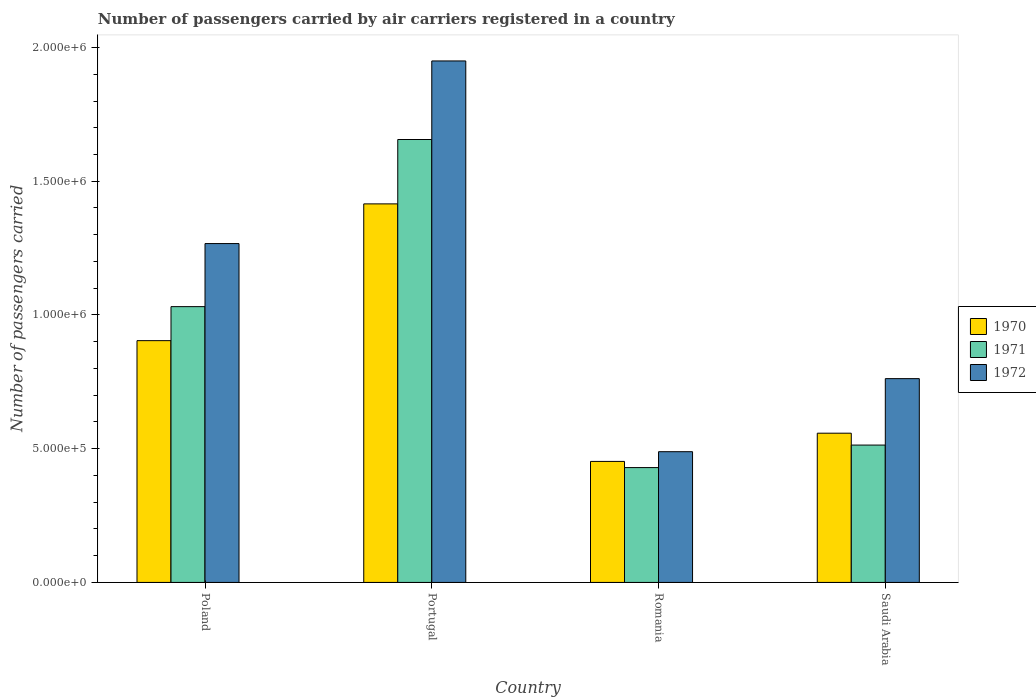How many different coloured bars are there?
Provide a succinct answer. 3. How many groups of bars are there?
Give a very brief answer. 4. Are the number of bars per tick equal to the number of legend labels?
Keep it short and to the point. Yes. How many bars are there on the 1st tick from the left?
Keep it short and to the point. 3. What is the number of passengers carried by air carriers in 1970 in Poland?
Ensure brevity in your answer.  9.04e+05. Across all countries, what is the maximum number of passengers carried by air carriers in 1972?
Provide a short and direct response. 1.95e+06. Across all countries, what is the minimum number of passengers carried by air carriers in 1972?
Offer a terse response. 4.89e+05. In which country was the number of passengers carried by air carriers in 1971 minimum?
Make the answer very short. Romania. What is the total number of passengers carried by air carriers in 1971 in the graph?
Offer a very short reply. 3.63e+06. What is the difference between the number of passengers carried by air carriers in 1970 in Poland and that in Romania?
Provide a short and direct response. 4.52e+05. What is the difference between the number of passengers carried by air carriers in 1971 in Poland and the number of passengers carried by air carriers in 1970 in Saudi Arabia?
Ensure brevity in your answer.  4.73e+05. What is the average number of passengers carried by air carriers in 1970 per country?
Provide a short and direct response. 8.32e+05. What is the difference between the number of passengers carried by air carriers of/in 1971 and number of passengers carried by air carriers of/in 1970 in Romania?
Provide a succinct answer. -2.31e+04. In how many countries, is the number of passengers carried by air carriers in 1971 greater than 1000000?
Offer a terse response. 2. What is the ratio of the number of passengers carried by air carriers in 1971 in Poland to that in Saudi Arabia?
Provide a short and direct response. 2.01. What is the difference between the highest and the second highest number of passengers carried by air carriers in 1970?
Your response must be concise. 5.11e+05. What is the difference between the highest and the lowest number of passengers carried by air carriers in 1971?
Your answer should be very brief. 1.23e+06. Is the sum of the number of passengers carried by air carriers in 1970 in Poland and Portugal greater than the maximum number of passengers carried by air carriers in 1971 across all countries?
Make the answer very short. Yes. What does the 2nd bar from the left in Poland represents?
Ensure brevity in your answer.  1971. How many bars are there?
Your answer should be compact. 12. How many countries are there in the graph?
Give a very brief answer. 4. Where does the legend appear in the graph?
Your answer should be very brief. Center right. What is the title of the graph?
Ensure brevity in your answer.  Number of passengers carried by air carriers registered in a country. What is the label or title of the X-axis?
Offer a terse response. Country. What is the label or title of the Y-axis?
Give a very brief answer. Number of passengers carried. What is the Number of passengers carried in 1970 in Poland?
Give a very brief answer. 9.04e+05. What is the Number of passengers carried in 1971 in Poland?
Offer a very short reply. 1.03e+06. What is the Number of passengers carried of 1972 in Poland?
Make the answer very short. 1.27e+06. What is the Number of passengers carried in 1970 in Portugal?
Your response must be concise. 1.42e+06. What is the Number of passengers carried in 1971 in Portugal?
Give a very brief answer. 1.66e+06. What is the Number of passengers carried of 1972 in Portugal?
Offer a terse response. 1.95e+06. What is the Number of passengers carried in 1970 in Romania?
Your answer should be very brief. 4.52e+05. What is the Number of passengers carried of 1971 in Romania?
Keep it short and to the point. 4.29e+05. What is the Number of passengers carried of 1972 in Romania?
Offer a terse response. 4.89e+05. What is the Number of passengers carried of 1970 in Saudi Arabia?
Give a very brief answer. 5.58e+05. What is the Number of passengers carried in 1971 in Saudi Arabia?
Offer a very short reply. 5.14e+05. What is the Number of passengers carried of 1972 in Saudi Arabia?
Provide a succinct answer. 7.62e+05. Across all countries, what is the maximum Number of passengers carried in 1970?
Give a very brief answer. 1.42e+06. Across all countries, what is the maximum Number of passengers carried of 1971?
Your answer should be compact. 1.66e+06. Across all countries, what is the maximum Number of passengers carried of 1972?
Ensure brevity in your answer.  1.95e+06. Across all countries, what is the minimum Number of passengers carried in 1970?
Offer a terse response. 4.52e+05. Across all countries, what is the minimum Number of passengers carried of 1971?
Make the answer very short. 4.29e+05. Across all countries, what is the minimum Number of passengers carried of 1972?
Provide a succinct answer. 4.89e+05. What is the total Number of passengers carried of 1970 in the graph?
Your response must be concise. 3.33e+06. What is the total Number of passengers carried of 1971 in the graph?
Your answer should be compact. 3.63e+06. What is the total Number of passengers carried of 1972 in the graph?
Ensure brevity in your answer.  4.47e+06. What is the difference between the Number of passengers carried in 1970 in Poland and that in Portugal?
Provide a short and direct response. -5.11e+05. What is the difference between the Number of passengers carried in 1971 in Poland and that in Portugal?
Your answer should be compact. -6.25e+05. What is the difference between the Number of passengers carried of 1972 in Poland and that in Portugal?
Your answer should be very brief. -6.83e+05. What is the difference between the Number of passengers carried of 1970 in Poland and that in Romania?
Give a very brief answer. 4.52e+05. What is the difference between the Number of passengers carried of 1971 in Poland and that in Romania?
Give a very brief answer. 6.02e+05. What is the difference between the Number of passengers carried of 1972 in Poland and that in Romania?
Provide a succinct answer. 7.78e+05. What is the difference between the Number of passengers carried in 1970 in Poland and that in Saudi Arabia?
Your response must be concise. 3.46e+05. What is the difference between the Number of passengers carried of 1971 in Poland and that in Saudi Arabia?
Your answer should be very brief. 5.18e+05. What is the difference between the Number of passengers carried of 1972 in Poland and that in Saudi Arabia?
Offer a terse response. 5.05e+05. What is the difference between the Number of passengers carried in 1970 in Portugal and that in Romania?
Offer a very short reply. 9.63e+05. What is the difference between the Number of passengers carried in 1971 in Portugal and that in Romania?
Your response must be concise. 1.23e+06. What is the difference between the Number of passengers carried of 1972 in Portugal and that in Romania?
Your response must be concise. 1.46e+06. What is the difference between the Number of passengers carried of 1970 in Portugal and that in Saudi Arabia?
Keep it short and to the point. 8.57e+05. What is the difference between the Number of passengers carried in 1971 in Portugal and that in Saudi Arabia?
Your answer should be compact. 1.14e+06. What is the difference between the Number of passengers carried in 1972 in Portugal and that in Saudi Arabia?
Provide a short and direct response. 1.19e+06. What is the difference between the Number of passengers carried in 1970 in Romania and that in Saudi Arabia?
Your answer should be compact. -1.06e+05. What is the difference between the Number of passengers carried of 1971 in Romania and that in Saudi Arabia?
Ensure brevity in your answer.  -8.42e+04. What is the difference between the Number of passengers carried of 1972 in Romania and that in Saudi Arabia?
Ensure brevity in your answer.  -2.73e+05. What is the difference between the Number of passengers carried of 1970 in Poland and the Number of passengers carried of 1971 in Portugal?
Ensure brevity in your answer.  -7.52e+05. What is the difference between the Number of passengers carried in 1970 in Poland and the Number of passengers carried in 1972 in Portugal?
Offer a very short reply. -1.05e+06. What is the difference between the Number of passengers carried of 1971 in Poland and the Number of passengers carried of 1972 in Portugal?
Ensure brevity in your answer.  -9.19e+05. What is the difference between the Number of passengers carried of 1970 in Poland and the Number of passengers carried of 1971 in Romania?
Give a very brief answer. 4.75e+05. What is the difference between the Number of passengers carried in 1970 in Poland and the Number of passengers carried in 1972 in Romania?
Your response must be concise. 4.15e+05. What is the difference between the Number of passengers carried of 1971 in Poland and the Number of passengers carried of 1972 in Romania?
Provide a short and direct response. 5.42e+05. What is the difference between the Number of passengers carried in 1970 in Poland and the Number of passengers carried in 1971 in Saudi Arabia?
Your answer should be compact. 3.90e+05. What is the difference between the Number of passengers carried in 1970 in Poland and the Number of passengers carried in 1972 in Saudi Arabia?
Your answer should be compact. 1.42e+05. What is the difference between the Number of passengers carried of 1971 in Poland and the Number of passengers carried of 1972 in Saudi Arabia?
Provide a short and direct response. 2.69e+05. What is the difference between the Number of passengers carried in 1970 in Portugal and the Number of passengers carried in 1971 in Romania?
Offer a terse response. 9.86e+05. What is the difference between the Number of passengers carried in 1970 in Portugal and the Number of passengers carried in 1972 in Romania?
Your answer should be compact. 9.27e+05. What is the difference between the Number of passengers carried in 1971 in Portugal and the Number of passengers carried in 1972 in Romania?
Provide a succinct answer. 1.17e+06. What is the difference between the Number of passengers carried in 1970 in Portugal and the Number of passengers carried in 1971 in Saudi Arabia?
Your answer should be compact. 9.02e+05. What is the difference between the Number of passengers carried in 1970 in Portugal and the Number of passengers carried in 1972 in Saudi Arabia?
Keep it short and to the point. 6.53e+05. What is the difference between the Number of passengers carried in 1971 in Portugal and the Number of passengers carried in 1972 in Saudi Arabia?
Provide a short and direct response. 8.94e+05. What is the difference between the Number of passengers carried in 1970 in Romania and the Number of passengers carried in 1971 in Saudi Arabia?
Your response must be concise. -6.11e+04. What is the difference between the Number of passengers carried of 1970 in Romania and the Number of passengers carried of 1972 in Saudi Arabia?
Your response must be concise. -3.10e+05. What is the difference between the Number of passengers carried in 1971 in Romania and the Number of passengers carried in 1972 in Saudi Arabia?
Provide a short and direct response. -3.33e+05. What is the average Number of passengers carried in 1970 per country?
Your answer should be compact. 8.32e+05. What is the average Number of passengers carried in 1971 per country?
Give a very brief answer. 9.08e+05. What is the average Number of passengers carried of 1972 per country?
Provide a short and direct response. 1.12e+06. What is the difference between the Number of passengers carried of 1970 and Number of passengers carried of 1971 in Poland?
Make the answer very short. -1.27e+05. What is the difference between the Number of passengers carried of 1970 and Number of passengers carried of 1972 in Poland?
Offer a very short reply. -3.63e+05. What is the difference between the Number of passengers carried of 1971 and Number of passengers carried of 1972 in Poland?
Your answer should be very brief. -2.36e+05. What is the difference between the Number of passengers carried of 1970 and Number of passengers carried of 1971 in Portugal?
Make the answer very short. -2.41e+05. What is the difference between the Number of passengers carried of 1970 and Number of passengers carried of 1972 in Portugal?
Give a very brief answer. -5.34e+05. What is the difference between the Number of passengers carried in 1971 and Number of passengers carried in 1972 in Portugal?
Your answer should be compact. -2.94e+05. What is the difference between the Number of passengers carried of 1970 and Number of passengers carried of 1971 in Romania?
Make the answer very short. 2.31e+04. What is the difference between the Number of passengers carried in 1970 and Number of passengers carried in 1972 in Romania?
Make the answer very short. -3.63e+04. What is the difference between the Number of passengers carried in 1971 and Number of passengers carried in 1972 in Romania?
Your response must be concise. -5.94e+04. What is the difference between the Number of passengers carried of 1970 and Number of passengers carried of 1971 in Saudi Arabia?
Your response must be concise. 4.44e+04. What is the difference between the Number of passengers carried in 1970 and Number of passengers carried in 1972 in Saudi Arabia?
Make the answer very short. -2.04e+05. What is the difference between the Number of passengers carried of 1971 and Number of passengers carried of 1972 in Saudi Arabia?
Your answer should be very brief. -2.48e+05. What is the ratio of the Number of passengers carried of 1970 in Poland to that in Portugal?
Your response must be concise. 0.64. What is the ratio of the Number of passengers carried of 1971 in Poland to that in Portugal?
Your answer should be compact. 0.62. What is the ratio of the Number of passengers carried of 1972 in Poland to that in Portugal?
Ensure brevity in your answer.  0.65. What is the ratio of the Number of passengers carried in 1970 in Poland to that in Romania?
Make the answer very short. 2. What is the ratio of the Number of passengers carried in 1971 in Poland to that in Romania?
Offer a terse response. 2.4. What is the ratio of the Number of passengers carried in 1972 in Poland to that in Romania?
Keep it short and to the point. 2.59. What is the ratio of the Number of passengers carried in 1970 in Poland to that in Saudi Arabia?
Your answer should be very brief. 1.62. What is the ratio of the Number of passengers carried in 1971 in Poland to that in Saudi Arabia?
Offer a terse response. 2.01. What is the ratio of the Number of passengers carried of 1972 in Poland to that in Saudi Arabia?
Give a very brief answer. 1.66. What is the ratio of the Number of passengers carried of 1970 in Portugal to that in Romania?
Your answer should be very brief. 3.13. What is the ratio of the Number of passengers carried in 1971 in Portugal to that in Romania?
Offer a terse response. 3.86. What is the ratio of the Number of passengers carried in 1972 in Portugal to that in Romania?
Offer a very short reply. 3.99. What is the ratio of the Number of passengers carried of 1970 in Portugal to that in Saudi Arabia?
Provide a succinct answer. 2.54. What is the ratio of the Number of passengers carried in 1971 in Portugal to that in Saudi Arabia?
Offer a very short reply. 3.22. What is the ratio of the Number of passengers carried in 1972 in Portugal to that in Saudi Arabia?
Your answer should be very brief. 2.56. What is the ratio of the Number of passengers carried of 1970 in Romania to that in Saudi Arabia?
Offer a terse response. 0.81. What is the ratio of the Number of passengers carried in 1971 in Romania to that in Saudi Arabia?
Keep it short and to the point. 0.84. What is the ratio of the Number of passengers carried in 1972 in Romania to that in Saudi Arabia?
Provide a short and direct response. 0.64. What is the difference between the highest and the second highest Number of passengers carried in 1970?
Ensure brevity in your answer.  5.11e+05. What is the difference between the highest and the second highest Number of passengers carried of 1971?
Offer a terse response. 6.25e+05. What is the difference between the highest and the second highest Number of passengers carried in 1972?
Offer a terse response. 6.83e+05. What is the difference between the highest and the lowest Number of passengers carried in 1970?
Offer a very short reply. 9.63e+05. What is the difference between the highest and the lowest Number of passengers carried of 1971?
Offer a terse response. 1.23e+06. What is the difference between the highest and the lowest Number of passengers carried in 1972?
Make the answer very short. 1.46e+06. 